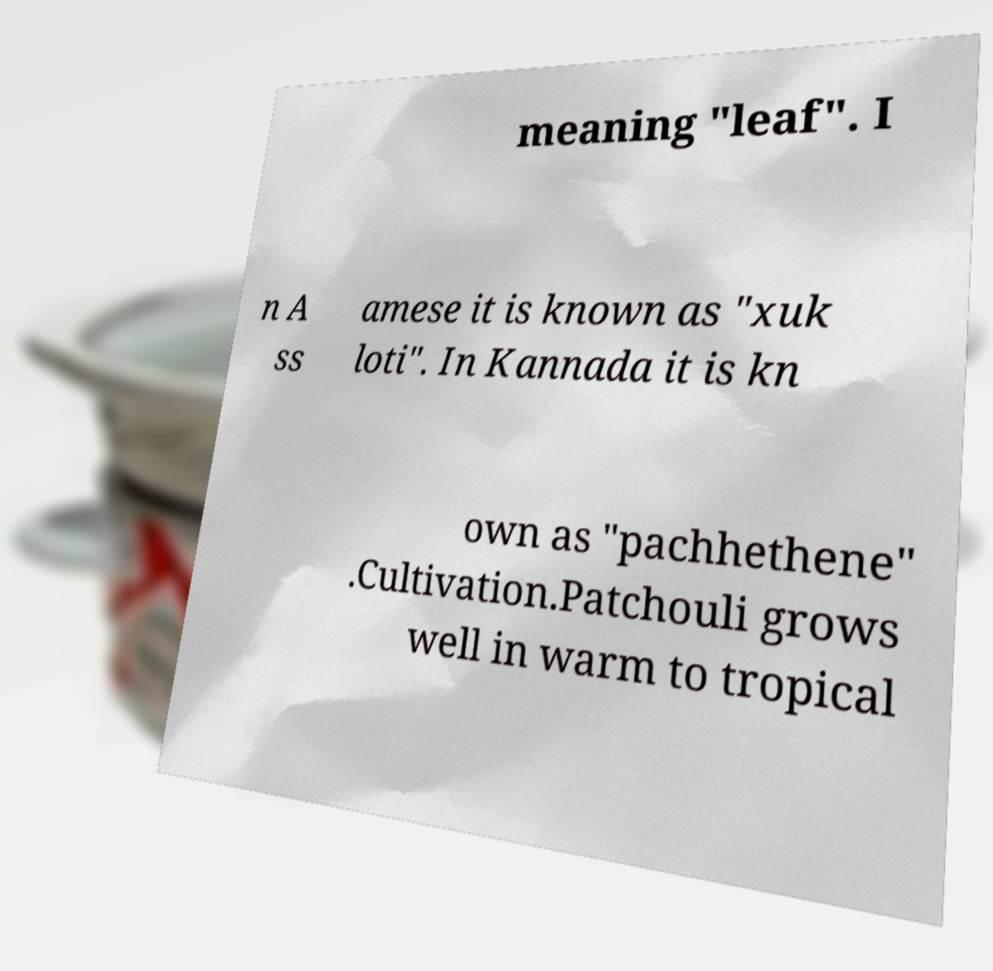Can you read and provide the text displayed in the image?This photo seems to have some interesting text. Can you extract and type it out for me? meaning "leaf". I n A ss amese it is known as "xuk loti". In Kannada it is kn own as "pachhethene" .Cultivation.Patchouli grows well in warm to tropical 